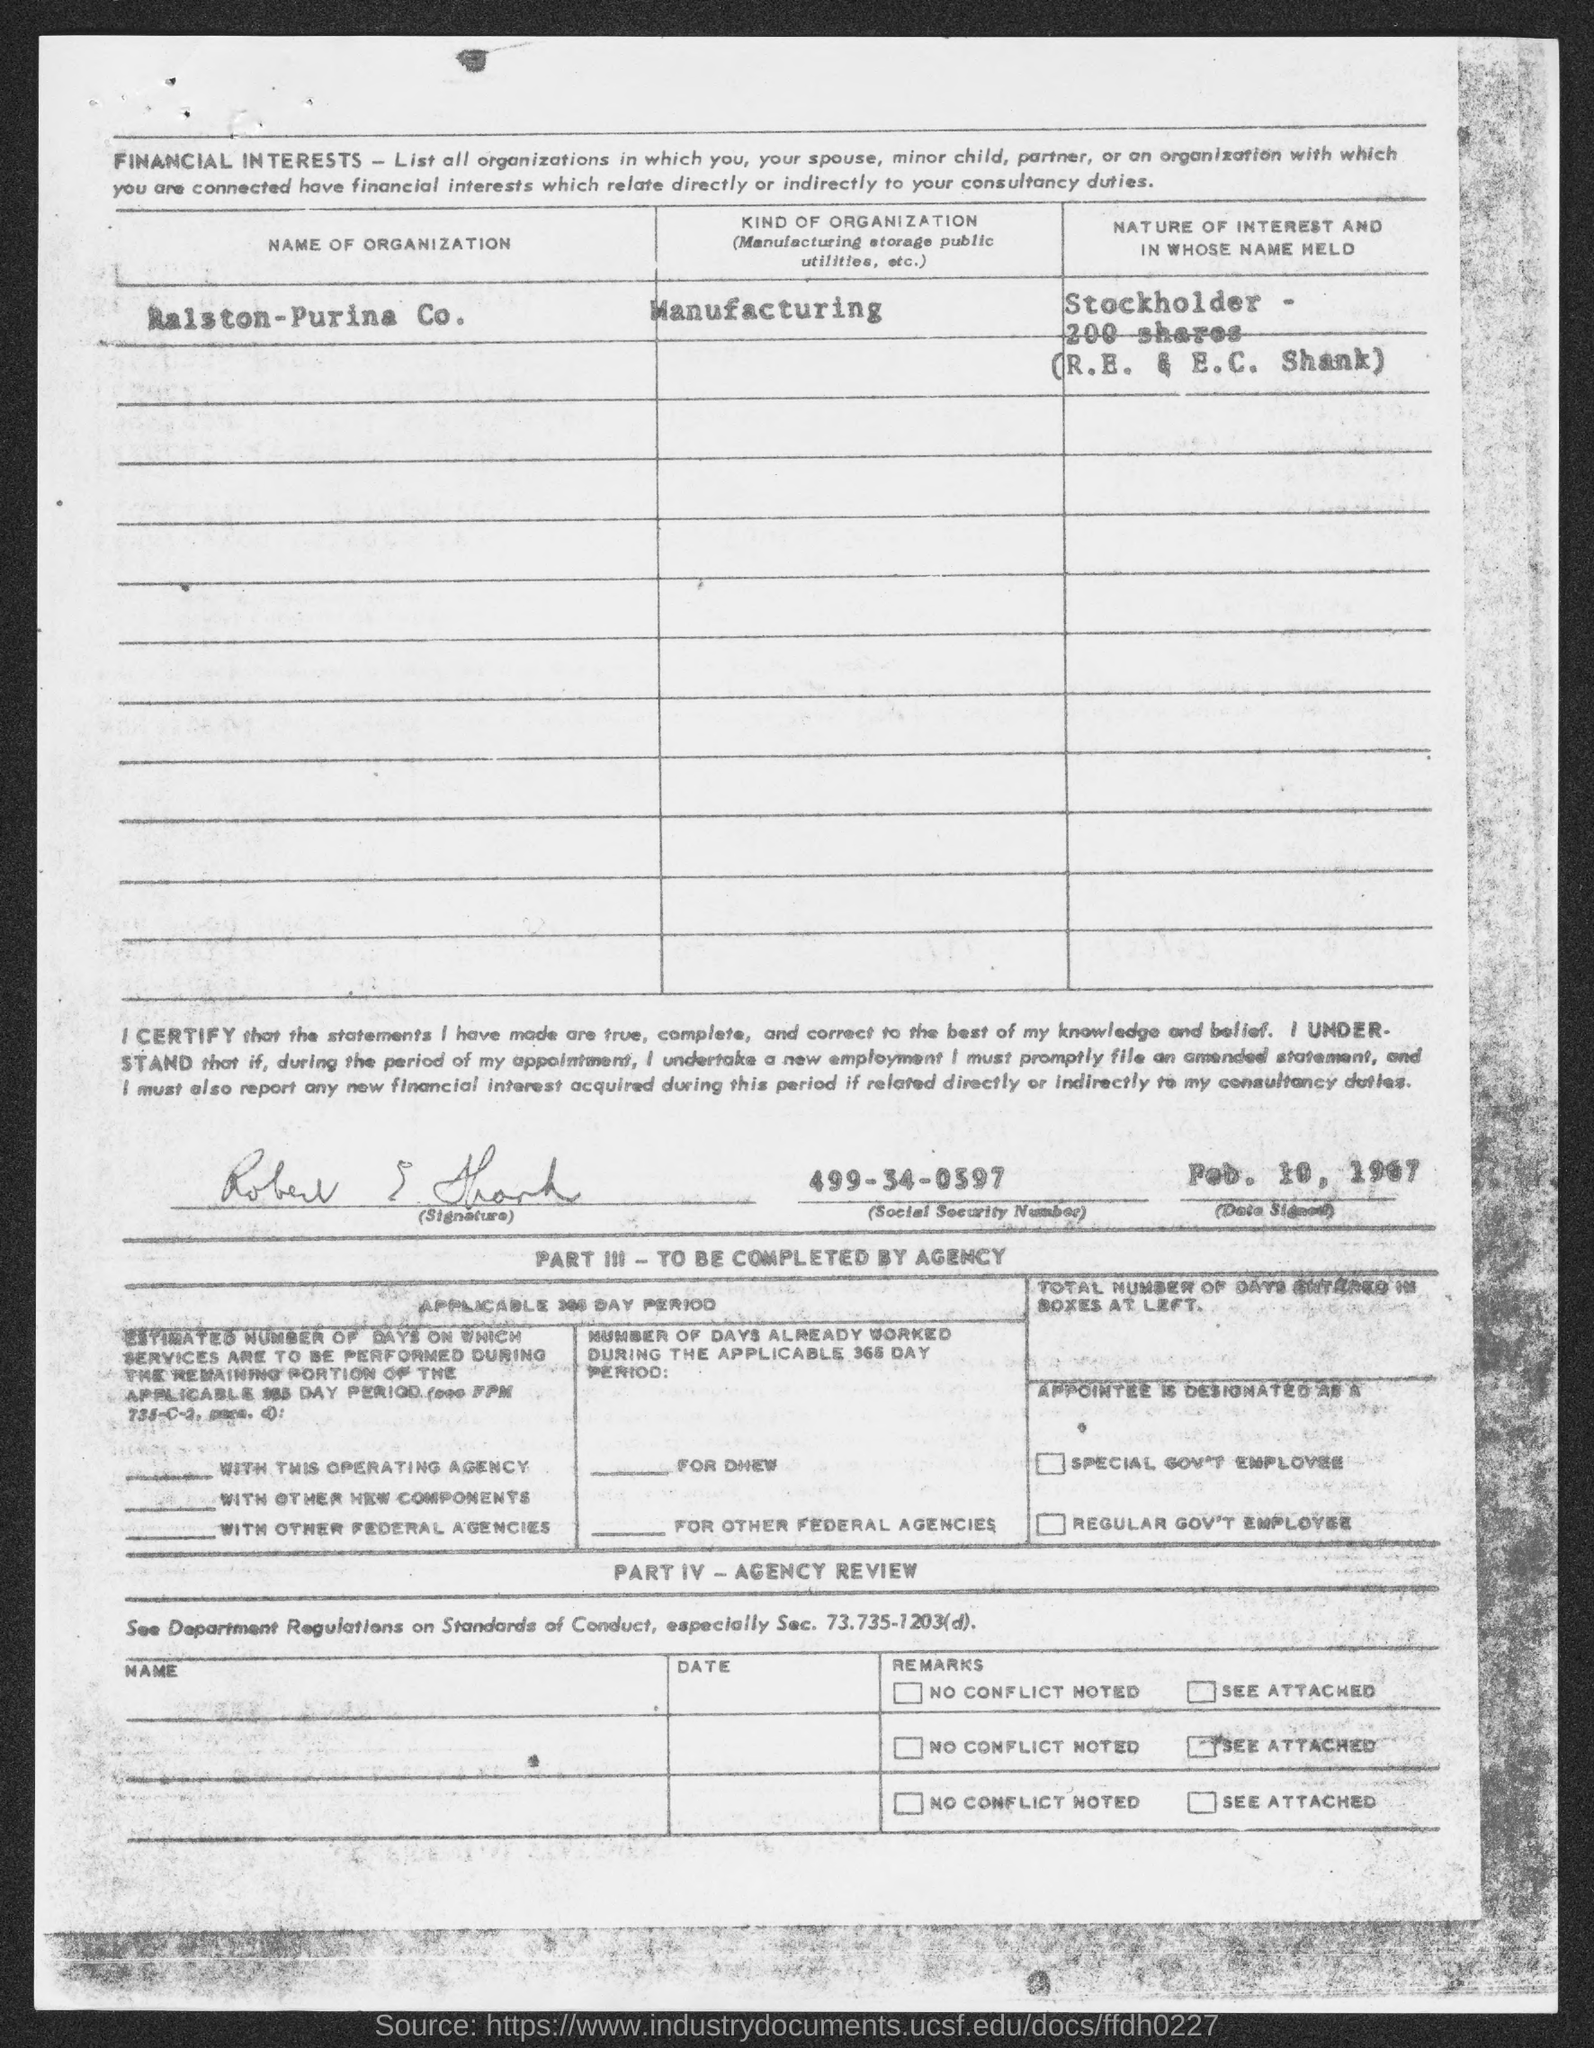What  is the name of organization given in the document?
Your response must be concise. RAISTON-PURINA CO. What is the kind of Organization mentioned in the document?
Provide a short and direct response. Manufacturing. What is the social security number given in the document?
Offer a terse response. 499-34-0397. What is the date signed as per the document?
Make the answer very short. FEB. 10, 1967. What is the nature of interest and in whose name it is held?
Your answer should be compact. STOCKHOLDER - 200 SHARES (R.E. & E.C. SHANK). 